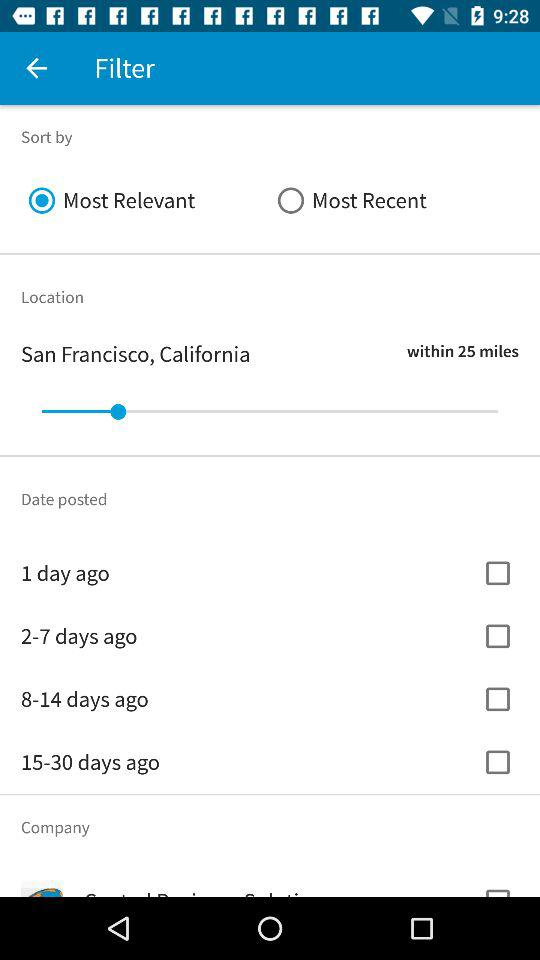Is "Most Relevant" selected or not? "Most Relevant" is selected. 